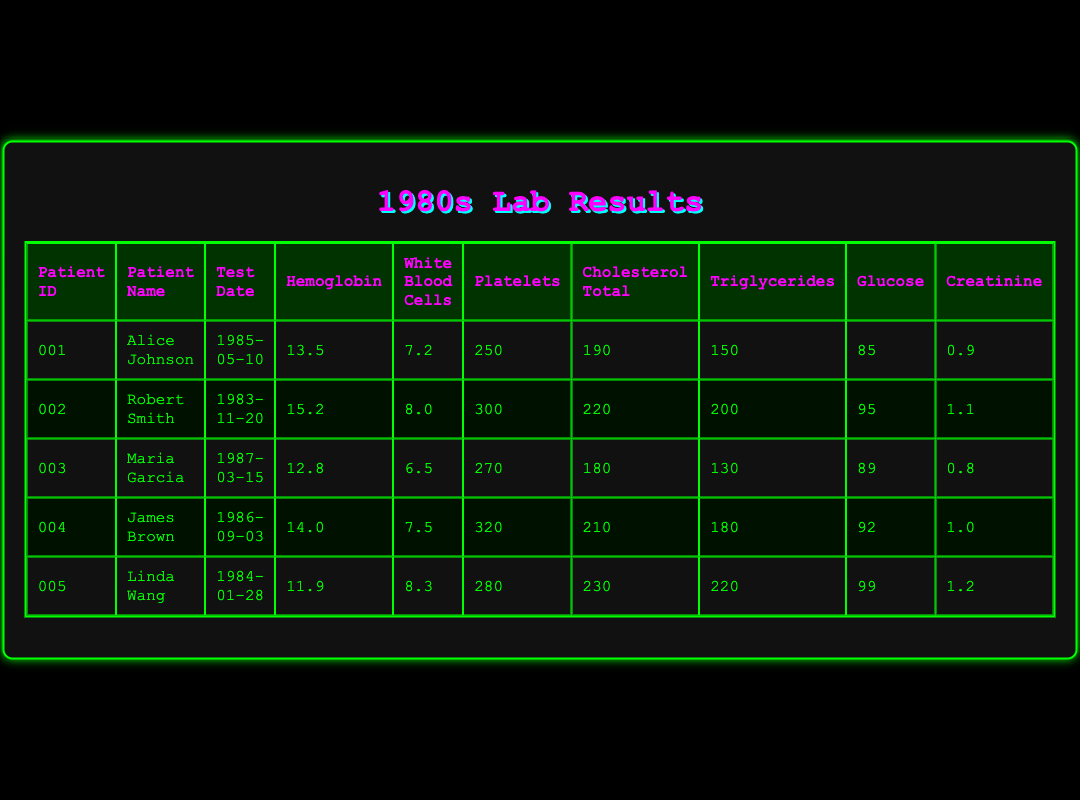What was the test date for Robert Smith? Robert Smith's test date is listed in the table under the "Test Date" column corresponding to his row. Looking at his entry, the date shows as "1983-11-20."
Answer: 1983-11-20 What is the hemoglobin level for Linda Wang? The hemoglobin level for Linda Wang can be found in her row in the "Hemoglobin" column. The value provided is "11.9."
Answer: 11.9 Which patient has the highest platelet count? To find the highest platelet count, we need to compare the "Platelets" values across all patients. From the table, James Brown has the highest platelet count at "320."
Answer: James Brown What is the average glucose level across all patients? We calculate the average glucose level by summing the glucose values (85 + 95 + 89 + 92 + 99 = 460) and then dividing by the number of patients (5). Therefore, 460 / 5 = 92.
Answer: 92 Is Alice Johnson's cholesterol total below 200? Looking at Alice Johnson's row in the "Cholesterol Total" column, the value is "190." Since 190 is below 200, the answer is yes.
Answer: Yes What is the difference in triglycerides between Robert Smith and Maria Garcia? To find the difference, we look at the "Triglycerides" column for both Robert Smith (200) and Maria Garcia (130). The difference is 200 - 130 = 70.
Answer: 70 How many patients have a creatinine level above 1.0? We need to check the "Creatinine" column. The values are: 0.9, 1.1, 0.8, 1.0, and 1.2. Only Robert Smith (1.1) and Linda Wang (1.2) have levels above 1.0. Thus, there are 2 patients.
Answer: 2 Which patient exhibits the lowest white blood cell count? To find the lowest white blood cell count, we examine the "White Blood Cells" column. The values are 7.2, 8.0, 6.5, 7.5, and 8.3. Maria Garcia has the lowest count at 6.5.
Answer: Maria Garcia What percentage of the patients have hemoglobin levels above 14.0? First, count the number of patients with hemoglobin above 14.0: Only Robert Smith (15.2) and James Brown (14.0) meet this criterion, totaling 2 patients out of 5. Then, calculate the percentage: (2 / 5) * 100 = 40%.
Answer: 40% 